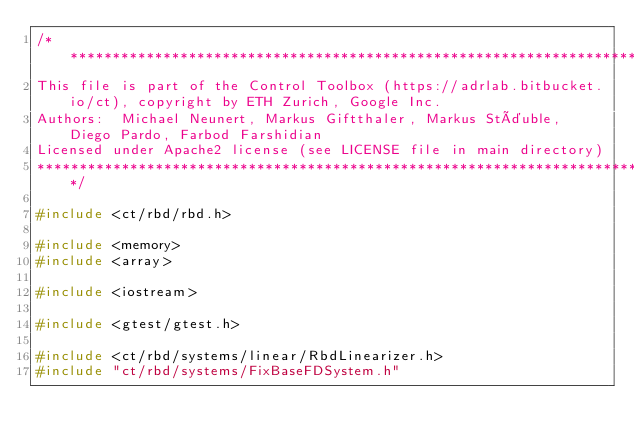Convert code to text. <code><loc_0><loc_0><loc_500><loc_500><_C++_>/**********************************************************************************************************************
This file is part of the Control Toolbox (https://adrlab.bitbucket.io/ct), copyright by ETH Zurich, Google Inc.
Authors:  Michael Neunert, Markus Giftthaler, Markus Stäuble, Diego Pardo, Farbod Farshidian
Licensed under Apache2 license (see LICENSE file in main directory)
**********************************************************************************************************************/

#include <ct/rbd/rbd.h>

#include <memory>
#include <array>

#include <iostream>

#include <gtest/gtest.h>

#include <ct/rbd/systems/linear/RbdLinearizer.h>
#include "ct/rbd/systems/FixBaseFDSystem.h"</code> 